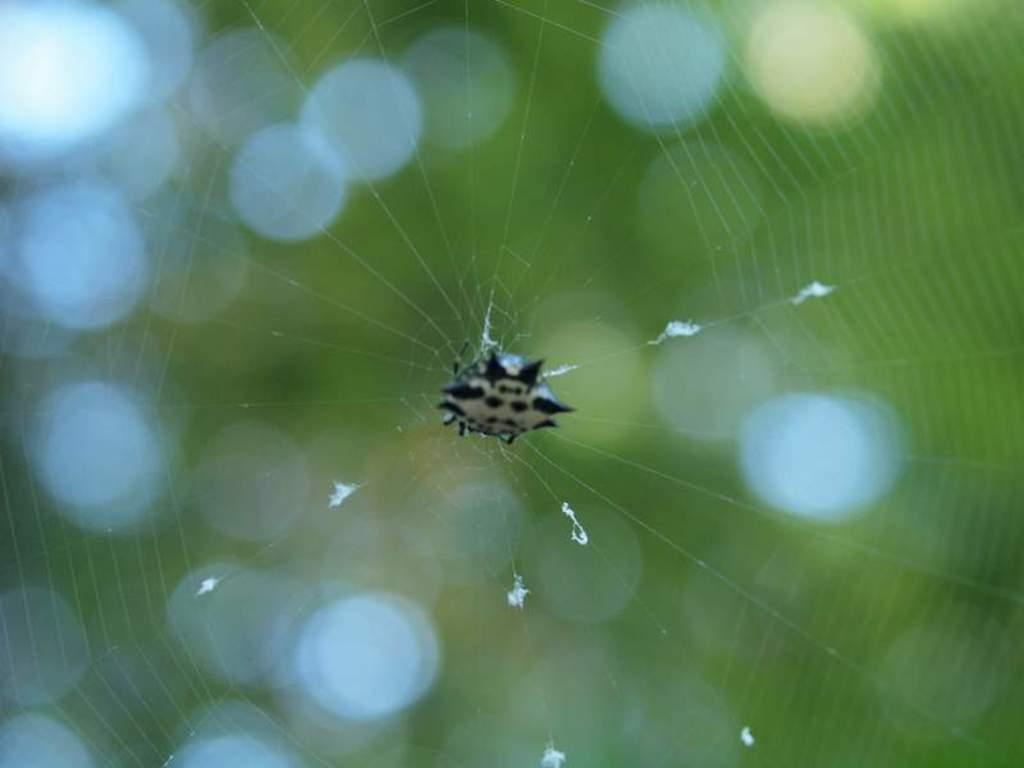Can you describe this image briefly? There is an insect on the spider web. 